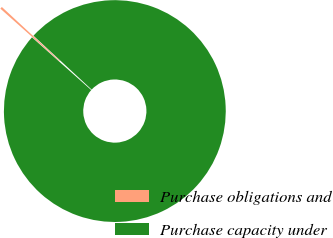<chart> <loc_0><loc_0><loc_500><loc_500><pie_chart><fcel>Purchase obligations and<fcel>Purchase capacity under<nl><fcel>0.32%<fcel>99.68%<nl></chart> 